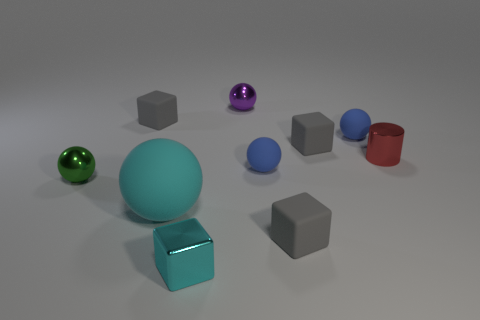What materials seem to be presented in the objects shown? The objects appear to be made from various materials, including what seems to be matte-finished metal for the green and purple spheres, glossy plastic for some of the cubes and the blue ball, as well as a reflective metal for the red and blue cylinders. 